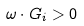<formula> <loc_0><loc_0><loc_500><loc_500>\omega \cdot G _ { i } > 0</formula> 